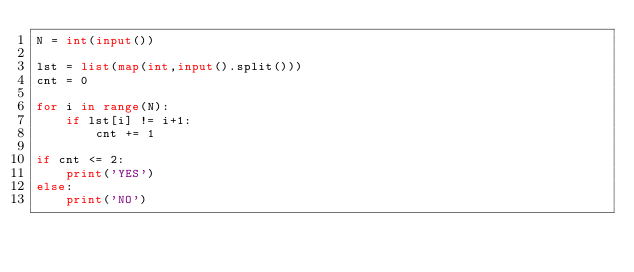Convert code to text. <code><loc_0><loc_0><loc_500><loc_500><_Python_>N = int(input())

lst = list(map(int,input().split()))
cnt = 0

for i in range(N):
    if lst[i] != i+1:
        cnt += 1

if cnt <= 2:
    print('YES')
else:
    print('NO')

</code> 